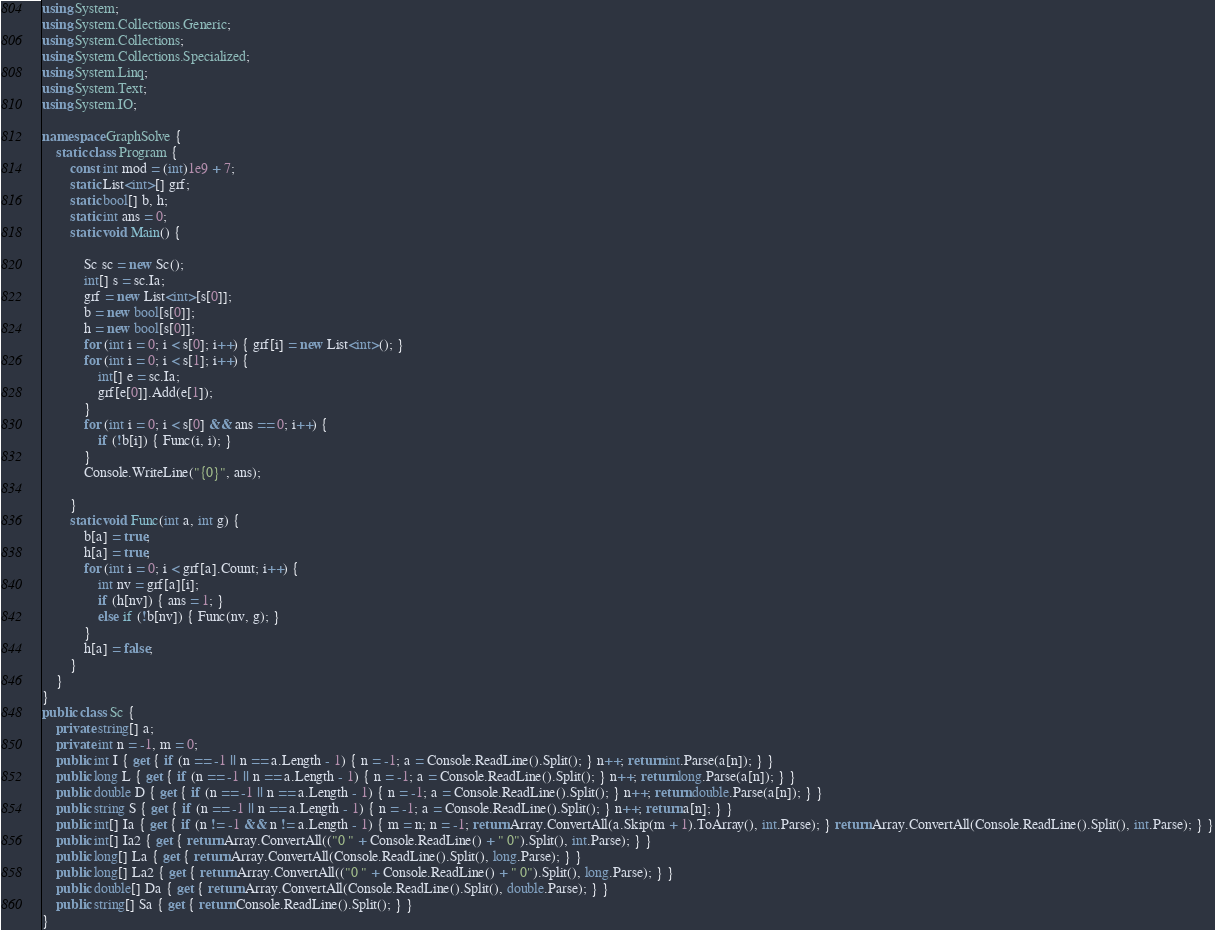<code> <loc_0><loc_0><loc_500><loc_500><_C#_>

using System;
using System.Collections.Generic;
using System.Collections;
using System.Collections.Specialized;
using System.Linq;
using System.Text;
using System.IO;

namespace GraphSolve {
    static class Program {
        const int mod = (int)1e9 + 7;
        static List<int>[] grf;
        static bool[] b, h;
        static int ans = 0;
        static void Main() {

            Sc sc = new Sc();
            int[] s = sc.Ia;
            grf = new List<int>[s[0]];
            b = new bool[s[0]];
            h = new bool[s[0]];
            for (int i = 0; i < s[0]; i++) { grf[i] = new List<int>(); }
            for (int i = 0; i < s[1]; i++) {
                int[] e = sc.Ia;
                grf[e[0]].Add(e[1]);
            }
            for (int i = 0; i < s[0] && ans == 0; i++) {
                if (!b[i]) { Func(i, i); }
            }
            Console.WriteLine("{0}", ans);

        }
        static void Func(int a, int g) {
            b[a] = true;
            h[a] = true;
            for (int i = 0; i < grf[a].Count; i++) {
                int nv = grf[a][i];
                if (h[nv]) { ans = 1; }
                else if (!b[nv]) { Func(nv, g); }
            }
            h[a] = false;
        }
    }
}
public class Sc {
    private string[] a;
    private int n = -1, m = 0;
    public int I { get { if (n == -1 || n == a.Length - 1) { n = -1; a = Console.ReadLine().Split(); } n++; return int.Parse(a[n]); } }
    public long L { get { if (n == -1 || n == a.Length - 1) { n = -1; a = Console.ReadLine().Split(); } n++; return long.Parse(a[n]); } }
    public double D { get { if (n == -1 || n == a.Length - 1) { n = -1; a = Console.ReadLine().Split(); } n++; return double.Parse(a[n]); } }
    public string S { get { if (n == -1 || n == a.Length - 1) { n = -1; a = Console.ReadLine().Split(); } n++; return a[n]; } }
    public int[] Ia { get { if (n != -1 && n != a.Length - 1) { m = n; n = -1; return Array.ConvertAll(a.Skip(m + 1).ToArray(), int.Parse); } return Array.ConvertAll(Console.ReadLine().Split(), int.Parse); } }
    public int[] Ia2 { get { return Array.ConvertAll(("0 " + Console.ReadLine() + " 0").Split(), int.Parse); } }
    public long[] La { get { return Array.ConvertAll(Console.ReadLine().Split(), long.Parse); } }
    public long[] La2 { get { return Array.ConvertAll(("0 " + Console.ReadLine() + " 0").Split(), long.Parse); } }
    public double[] Da { get { return Array.ConvertAll(Console.ReadLine().Split(), double.Parse); } }
    public string[] Sa { get { return Console.ReadLine().Split(); } }
}

</code> 